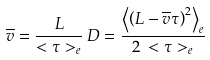<formula> <loc_0><loc_0><loc_500><loc_500>\overline { v } = \frac { L } { < \tau > _ { e } } \, D = \frac { \left < \left ( L - \overline { v } \tau \right ) ^ { 2 } \right > _ { e } } { 2 \, < \tau > _ { e } }</formula> 